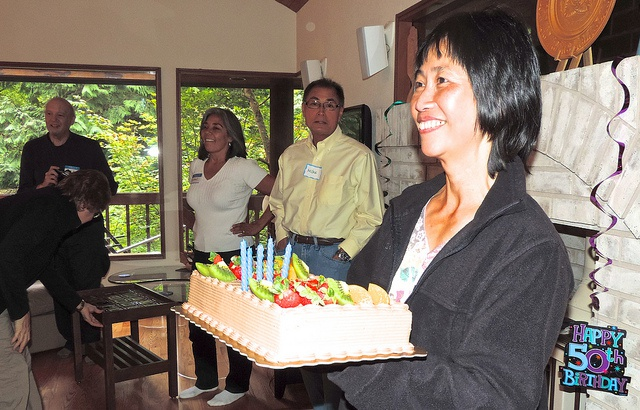Describe the objects in this image and their specific colors. I can see people in gray, black, and white tones, cake in gray, white, khaki, and tan tones, people in gray, khaki, and tan tones, people in gray and black tones, and people in gray, darkgray, black, maroon, and brown tones in this image. 